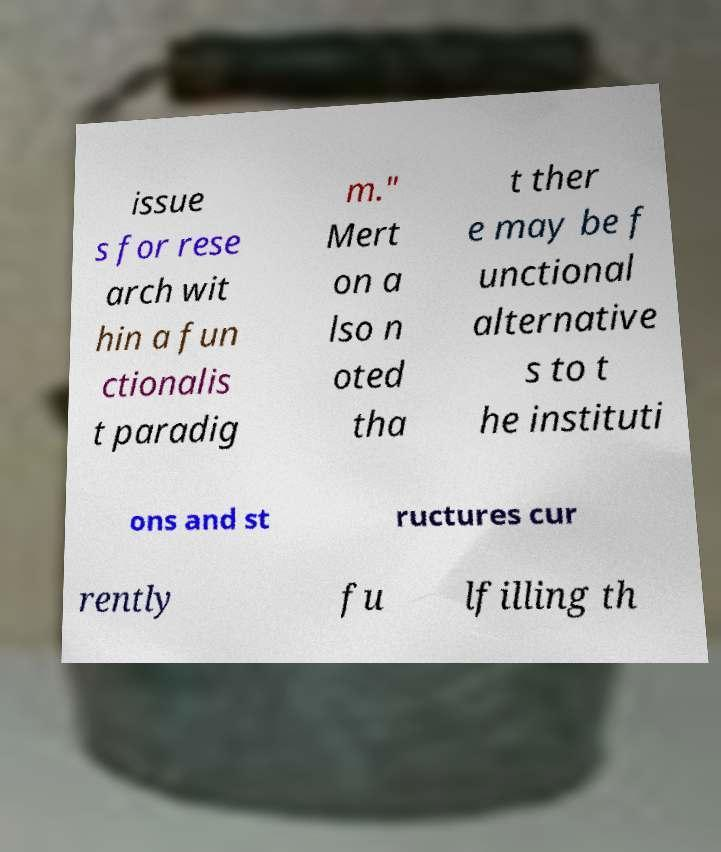Please identify and transcribe the text found in this image. issue s for rese arch wit hin a fun ctionalis t paradig m." Mert on a lso n oted tha t ther e may be f unctional alternative s to t he instituti ons and st ructures cur rently fu lfilling th 